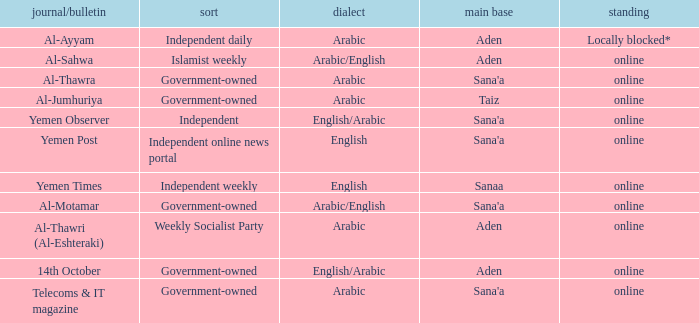What is Status, when Newspaper/Magazine is Al-Thawra? Online. 